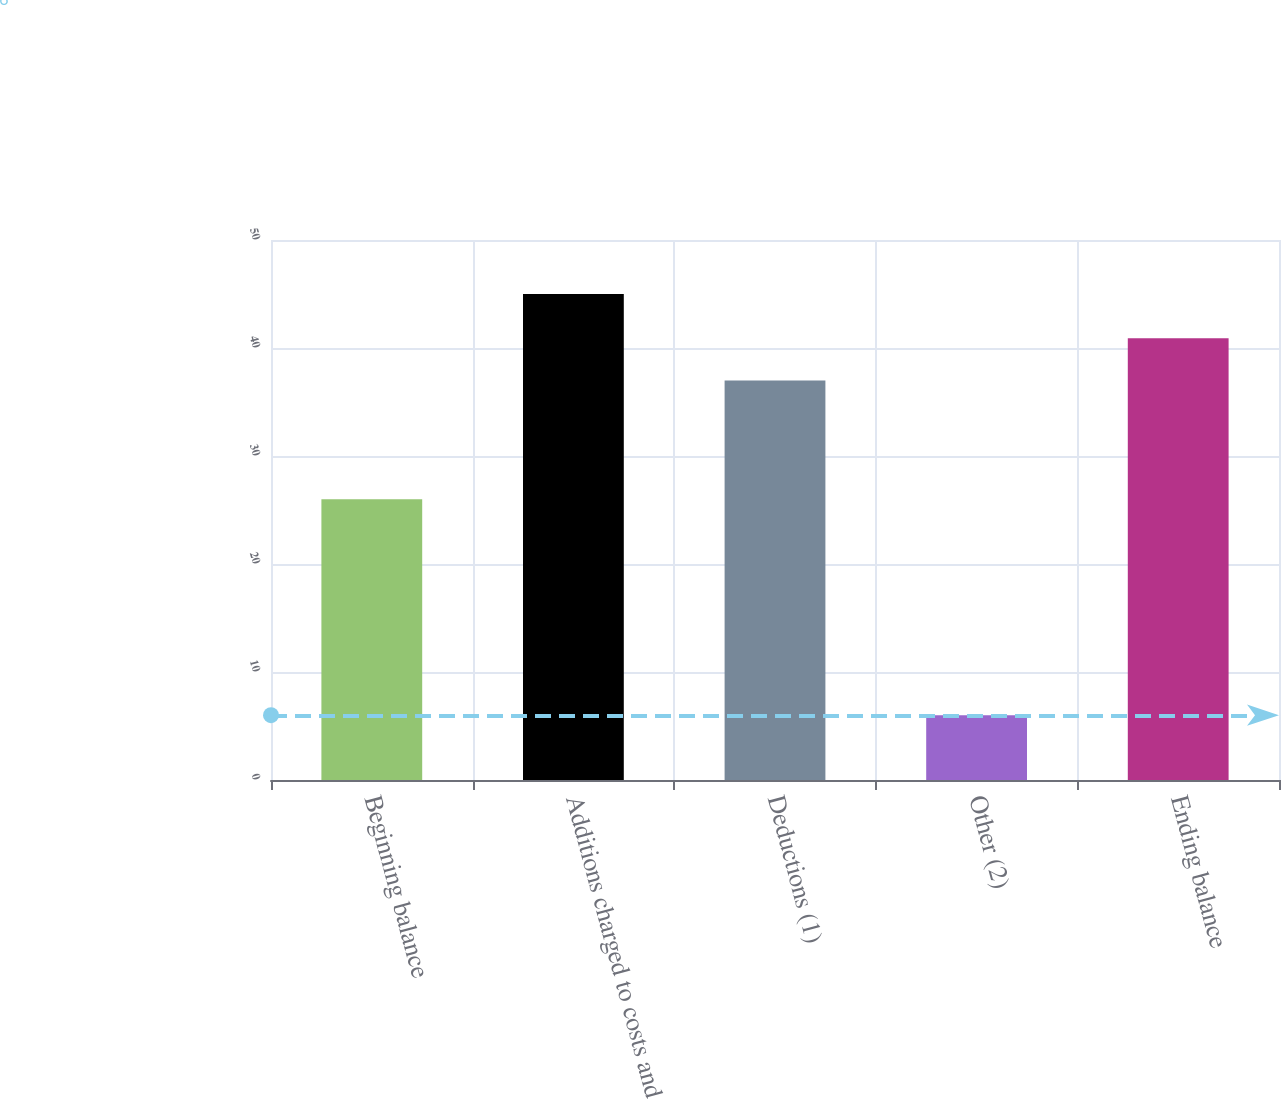Convert chart. <chart><loc_0><loc_0><loc_500><loc_500><bar_chart><fcel>Beginning balance<fcel>Additions charged to costs and<fcel>Deductions (1)<fcel>Other (2)<fcel>Ending balance<nl><fcel>26<fcel>45<fcel>37<fcel>6<fcel>40.9<nl></chart> 